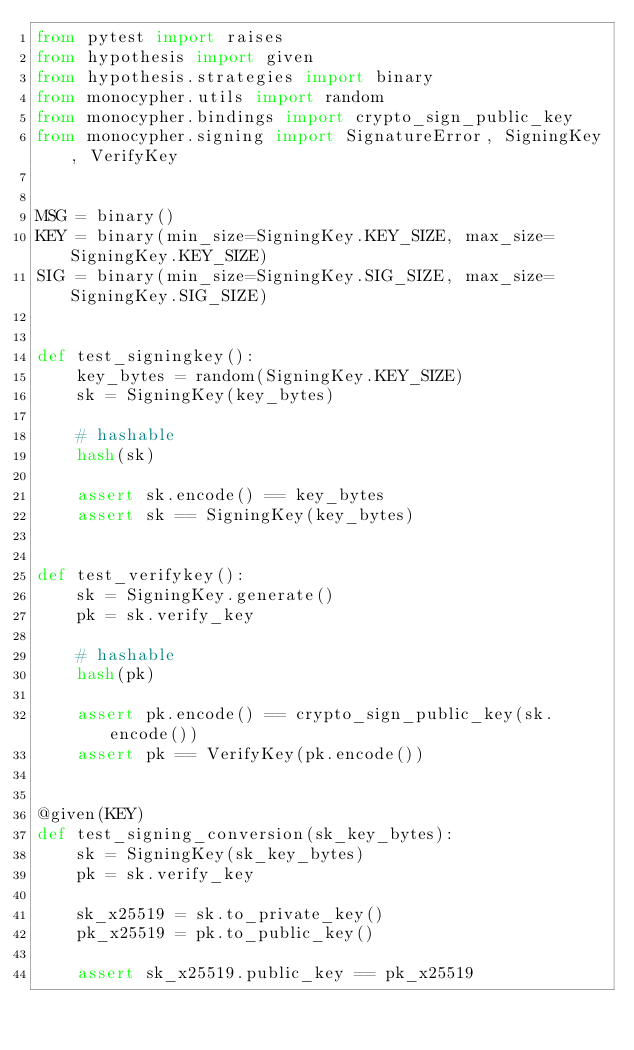Convert code to text. <code><loc_0><loc_0><loc_500><loc_500><_Python_>from pytest import raises
from hypothesis import given
from hypothesis.strategies import binary
from monocypher.utils import random
from monocypher.bindings import crypto_sign_public_key
from monocypher.signing import SignatureError, SigningKey, VerifyKey


MSG = binary()
KEY = binary(min_size=SigningKey.KEY_SIZE, max_size=SigningKey.KEY_SIZE)
SIG = binary(min_size=SigningKey.SIG_SIZE, max_size=SigningKey.SIG_SIZE)


def test_signingkey():
    key_bytes = random(SigningKey.KEY_SIZE)
    sk = SigningKey(key_bytes)

    # hashable
    hash(sk)

    assert sk.encode() == key_bytes
    assert sk == SigningKey(key_bytes)


def test_verifykey():
    sk = SigningKey.generate()
    pk = sk.verify_key

    # hashable
    hash(pk)

    assert pk.encode() == crypto_sign_public_key(sk.encode())
    assert pk == VerifyKey(pk.encode())


@given(KEY)
def test_signing_conversion(sk_key_bytes):
    sk = SigningKey(sk_key_bytes)
    pk = sk.verify_key

    sk_x25519 = sk.to_private_key()
    pk_x25519 = pk.to_public_key()

    assert sk_x25519.public_key == pk_x25519

</code> 